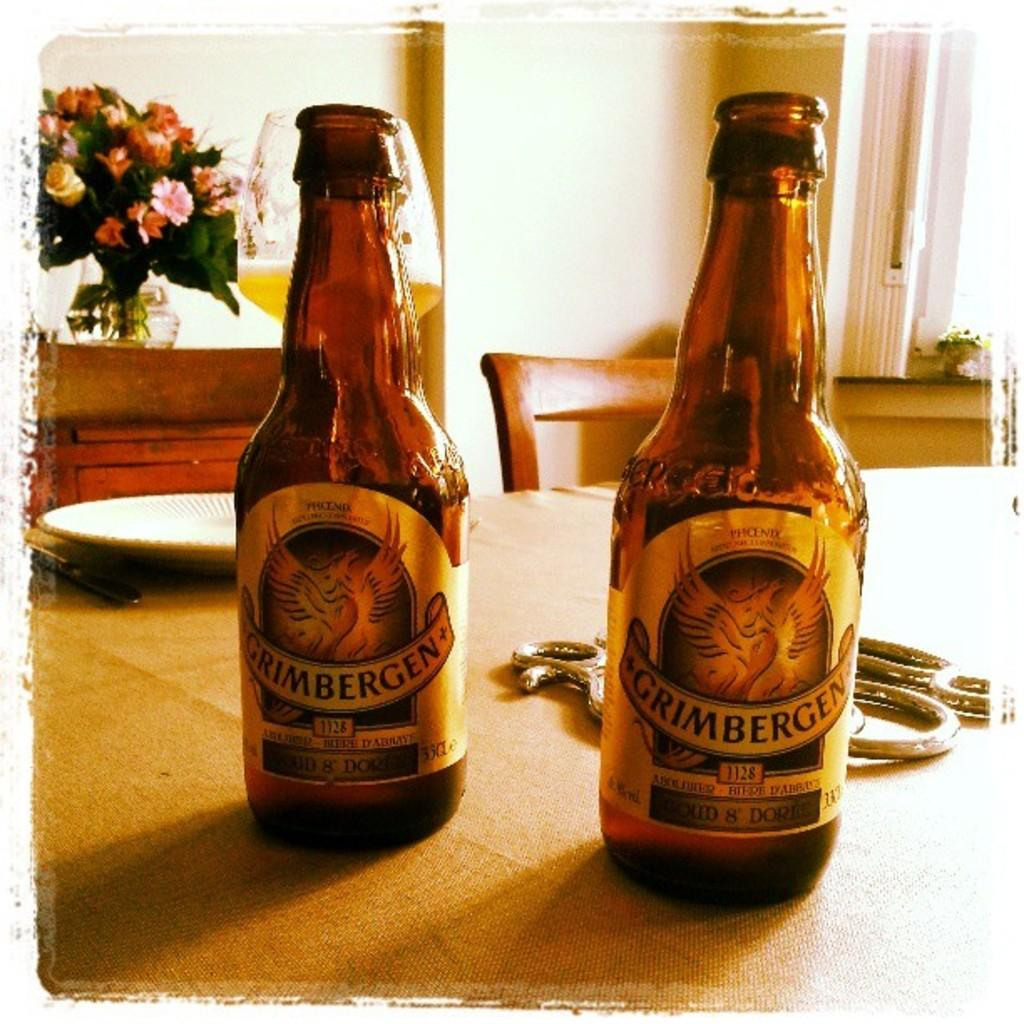<image>
Offer a succinct explanation of the picture presented. Two bottles of Grimbergen sit next to each other on a table. 